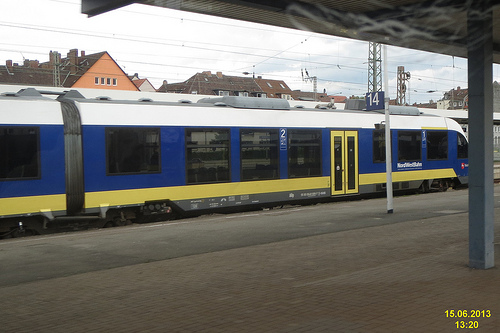Are there both a fence and a train in the photograph? There is a train visible in the photograph on the tracks, but I do not see a fence within this frame. 